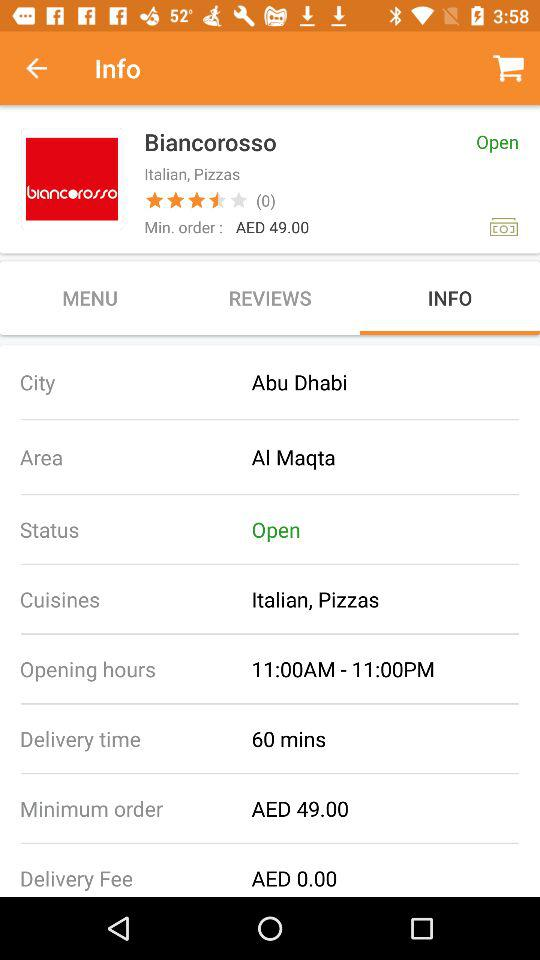What is the minimum order amount at Biancorosso?
Answer the question using a single word or phrase. AED 49.00 